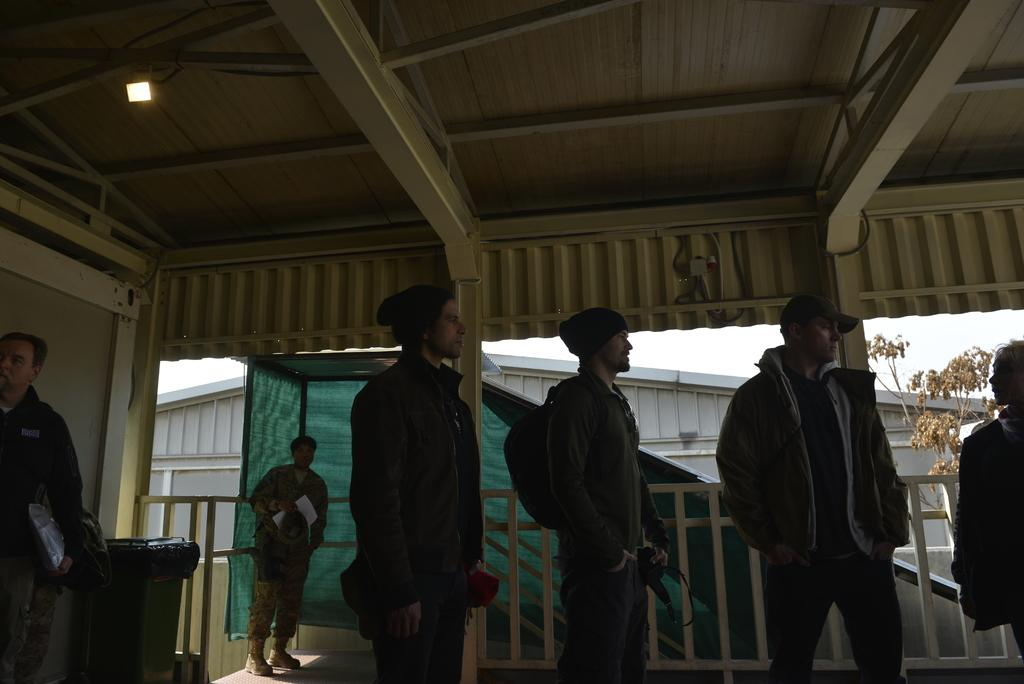What can be seen in the image? There are men standing in the image. Where are the men standing? The men are standing on the floor. What can be seen in the background of the image? There is cloth, a shed, bins, and the sky visible in the background of the image. Who is the creator of the potato in the image? There is no potato present in the image, so it is not possible to determine who its creator might be. 